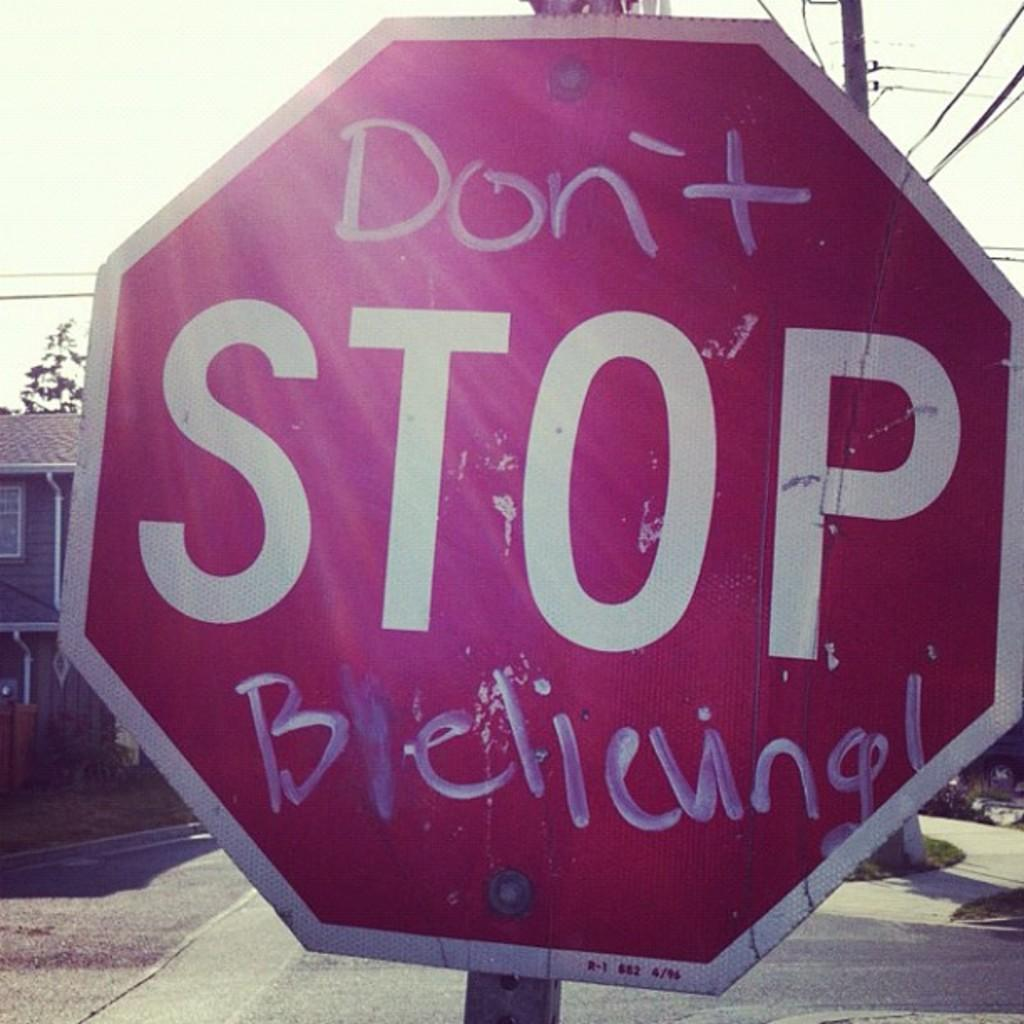<image>
Create a compact narrative representing the image presented. A Stop sign at an intersection has graffiti painted on top of and blew the word Stop. 